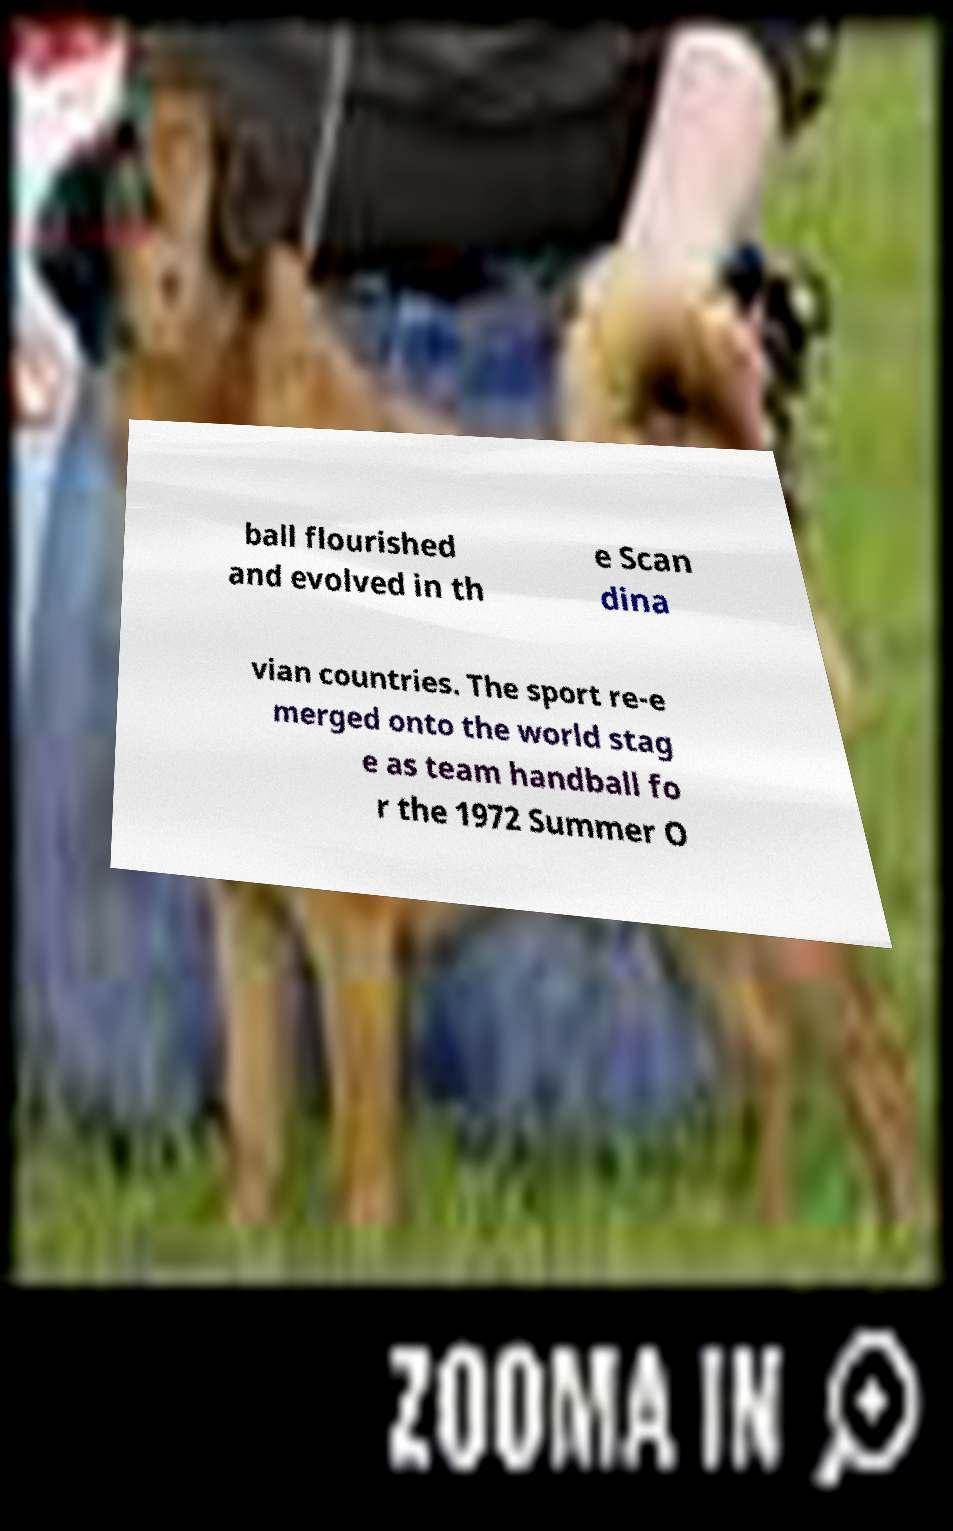Please identify and transcribe the text found in this image. ball flourished and evolved in th e Scan dina vian countries. The sport re-e merged onto the world stag e as team handball fo r the 1972 Summer O 